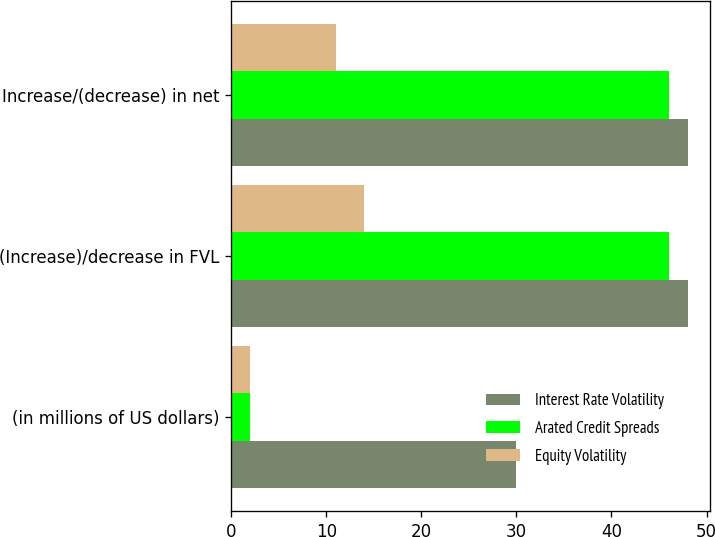<chart> <loc_0><loc_0><loc_500><loc_500><stacked_bar_chart><ecel><fcel>(in millions of US dollars)<fcel>(Increase)/decrease in FVL<fcel>Increase/(decrease) in net<nl><fcel>Interest Rate Volatility<fcel>30<fcel>48<fcel>48<nl><fcel>Arated Credit Spreads<fcel>2<fcel>46<fcel>46<nl><fcel>Equity Volatility<fcel>2<fcel>14<fcel>11<nl></chart> 